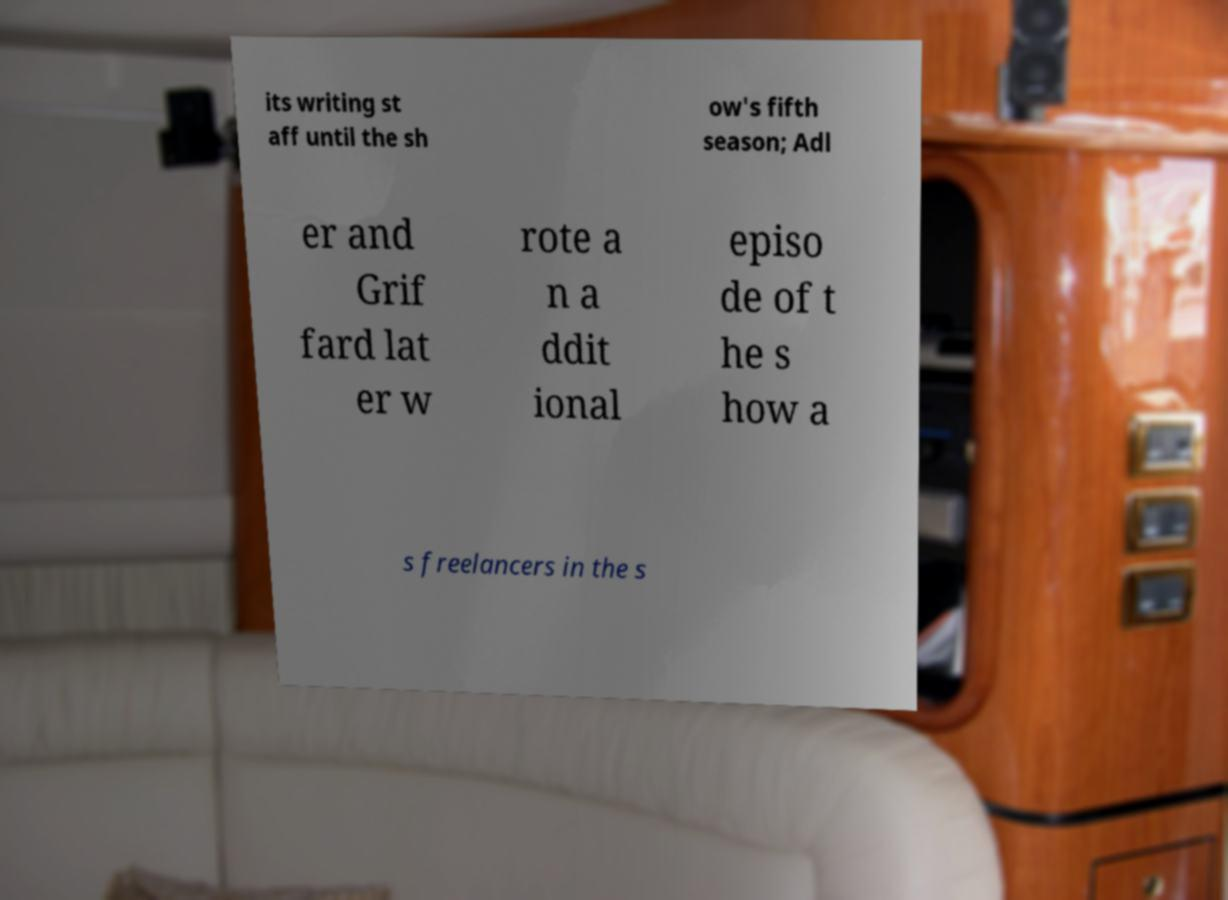For documentation purposes, I need the text within this image transcribed. Could you provide that? its writing st aff until the sh ow's fifth season; Adl er and Grif fard lat er w rote a n a ddit ional episo de of t he s how a s freelancers in the s 